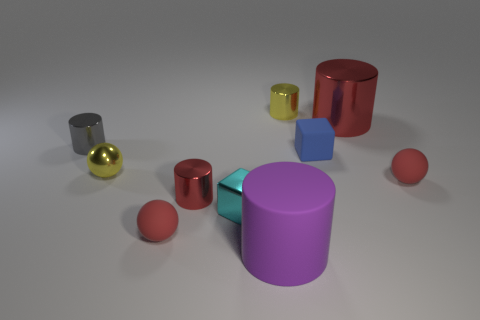Subtract all red matte balls. How many balls are left? 1 Subtract all yellow balls. How many balls are left? 2 Subtract all cubes. How many objects are left? 8 Subtract all red balls. How many red cylinders are left? 2 Subtract 0 green cylinders. How many objects are left? 10 Subtract 2 spheres. How many spheres are left? 1 Subtract all blue blocks. Subtract all red spheres. How many blocks are left? 1 Subtract all cyan objects. Subtract all big metal things. How many objects are left? 8 Add 8 tiny gray cylinders. How many tiny gray cylinders are left? 9 Add 6 small green objects. How many small green objects exist? 6 